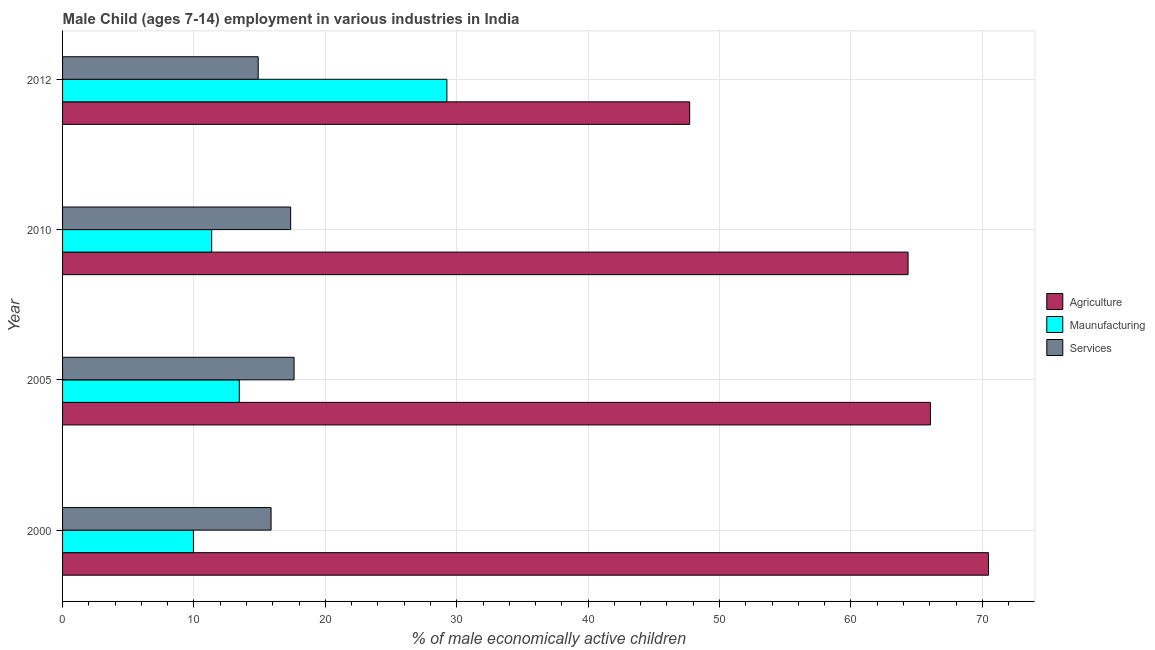How many different coloured bars are there?
Provide a succinct answer. 3. How many groups of bars are there?
Give a very brief answer. 4. How many bars are there on the 4th tick from the top?
Ensure brevity in your answer.  3. What is the percentage of economically active children in agriculture in 2010?
Your response must be concise. 64.35. Across all years, what is the maximum percentage of economically active children in agriculture?
Make the answer very short. 70.47. Across all years, what is the minimum percentage of economically active children in manufacturing?
Keep it short and to the point. 9.96. What is the total percentage of economically active children in manufacturing in the graph?
Provide a short and direct response. 64.01. What is the difference between the percentage of economically active children in services in 2000 and that in 2010?
Give a very brief answer. -1.49. What is the difference between the percentage of economically active children in agriculture in 2005 and the percentage of economically active children in manufacturing in 2012?
Your response must be concise. 36.8. What is the average percentage of economically active children in manufacturing per year?
Ensure brevity in your answer.  16. In the year 2010, what is the difference between the percentage of economically active children in manufacturing and percentage of economically active children in services?
Your answer should be compact. -6.01. In how many years, is the percentage of economically active children in manufacturing greater than 46 %?
Your response must be concise. 0. What is the ratio of the percentage of economically active children in agriculture in 2010 to that in 2012?
Your response must be concise. 1.35. Is the difference between the percentage of economically active children in manufacturing in 2000 and 2010 greater than the difference between the percentage of economically active children in agriculture in 2000 and 2010?
Your answer should be compact. No. What is the difference between the highest and the second highest percentage of economically active children in agriculture?
Your answer should be very brief. 4.42. What is the difference between the highest and the lowest percentage of economically active children in services?
Give a very brief answer. 2.73. What does the 3rd bar from the top in 2000 represents?
Your answer should be very brief. Agriculture. What does the 2nd bar from the bottom in 2012 represents?
Give a very brief answer. Maunufacturing. How many bars are there?
Your response must be concise. 12. What is the difference between two consecutive major ticks on the X-axis?
Offer a terse response. 10. Are the values on the major ticks of X-axis written in scientific E-notation?
Make the answer very short. No. Does the graph contain any zero values?
Your answer should be very brief. No. Where does the legend appear in the graph?
Your response must be concise. Center right. How many legend labels are there?
Your response must be concise. 3. How are the legend labels stacked?
Provide a short and direct response. Vertical. What is the title of the graph?
Offer a very short reply. Male Child (ages 7-14) employment in various industries in India. What is the label or title of the X-axis?
Offer a very short reply. % of male economically active children. What is the % of male economically active children in Agriculture in 2000?
Your answer should be very brief. 70.47. What is the % of male economically active children of Maunufacturing in 2000?
Your answer should be compact. 9.96. What is the % of male economically active children in Services in 2000?
Your answer should be compact. 15.87. What is the % of male economically active children in Agriculture in 2005?
Your response must be concise. 66.05. What is the % of male economically active children of Maunufacturing in 2005?
Provide a short and direct response. 13.45. What is the % of male economically active children of Services in 2005?
Give a very brief answer. 17.62. What is the % of male economically active children of Agriculture in 2010?
Your answer should be very brief. 64.35. What is the % of male economically active children in Maunufacturing in 2010?
Your answer should be very brief. 11.35. What is the % of male economically active children of Services in 2010?
Ensure brevity in your answer.  17.36. What is the % of male economically active children of Agriculture in 2012?
Keep it short and to the point. 47.73. What is the % of male economically active children of Maunufacturing in 2012?
Your answer should be very brief. 29.25. What is the % of male economically active children of Services in 2012?
Your response must be concise. 14.89. Across all years, what is the maximum % of male economically active children in Agriculture?
Your answer should be very brief. 70.47. Across all years, what is the maximum % of male economically active children of Maunufacturing?
Provide a succinct answer. 29.25. Across all years, what is the maximum % of male economically active children in Services?
Provide a succinct answer. 17.62. Across all years, what is the minimum % of male economically active children in Agriculture?
Provide a short and direct response. 47.73. Across all years, what is the minimum % of male economically active children of Maunufacturing?
Ensure brevity in your answer.  9.96. Across all years, what is the minimum % of male economically active children in Services?
Give a very brief answer. 14.89. What is the total % of male economically active children in Agriculture in the graph?
Offer a very short reply. 248.6. What is the total % of male economically active children of Maunufacturing in the graph?
Make the answer very short. 64.01. What is the total % of male economically active children in Services in the graph?
Ensure brevity in your answer.  65.74. What is the difference between the % of male economically active children in Agriculture in 2000 and that in 2005?
Provide a succinct answer. 4.42. What is the difference between the % of male economically active children of Maunufacturing in 2000 and that in 2005?
Provide a short and direct response. -3.49. What is the difference between the % of male economically active children of Services in 2000 and that in 2005?
Provide a short and direct response. -1.75. What is the difference between the % of male economically active children in Agriculture in 2000 and that in 2010?
Your answer should be compact. 6.12. What is the difference between the % of male economically active children of Maunufacturing in 2000 and that in 2010?
Provide a short and direct response. -1.39. What is the difference between the % of male economically active children in Services in 2000 and that in 2010?
Give a very brief answer. -1.49. What is the difference between the % of male economically active children in Agriculture in 2000 and that in 2012?
Your answer should be compact. 22.74. What is the difference between the % of male economically active children in Maunufacturing in 2000 and that in 2012?
Your answer should be very brief. -19.29. What is the difference between the % of male economically active children in Services in 2000 and that in 2012?
Keep it short and to the point. 0.98. What is the difference between the % of male economically active children of Agriculture in 2005 and that in 2010?
Provide a succinct answer. 1.7. What is the difference between the % of male economically active children of Services in 2005 and that in 2010?
Provide a succinct answer. 0.26. What is the difference between the % of male economically active children of Agriculture in 2005 and that in 2012?
Make the answer very short. 18.32. What is the difference between the % of male economically active children in Maunufacturing in 2005 and that in 2012?
Keep it short and to the point. -15.8. What is the difference between the % of male economically active children of Services in 2005 and that in 2012?
Provide a short and direct response. 2.73. What is the difference between the % of male economically active children of Agriculture in 2010 and that in 2012?
Offer a very short reply. 16.62. What is the difference between the % of male economically active children in Maunufacturing in 2010 and that in 2012?
Ensure brevity in your answer.  -17.9. What is the difference between the % of male economically active children of Services in 2010 and that in 2012?
Your answer should be very brief. 2.47. What is the difference between the % of male economically active children of Agriculture in 2000 and the % of male economically active children of Maunufacturing in 2005?
Give a very brief answer. 57.02. What is the difference between the % of male economically active children in Agriculture in 2000 and the % of male economically active children in Services in 2005?
Ensure brevity in your answer.  52.85. What is the difference between the % of male economically active children of Maunufacturing in 2000 and the % of male economically active children of Services in 2005?
Keep it short and to the point. -7.66. What is the difference between the % of male economically active children of Agriculture in 2000 and the % of male economically active children of Maunufacturing in 2010?
Ensure brevity in your answer.  59.12. What is the difference between the % of male economically active children in Agriculture in 2000 and the % of male economically active children in Services in 2010?
Your response must be concise. 53.11. What is the difference between the % of male economically active children of Maunufacturing in 2000 and the % of male economically active children of Services in 2010?
Make the answer very short. -7.4. What is the difference between the % of male economically active children of Agriculture in 2000 and the % of male economically active children of Maunufacturing in 2012?
Provide a short and direct response. 41.22. What is the difference between the % of male economically active children of Agriculture in 2000 and the % of male economically active children of Services in 2012?
Give a very brief answer. 55.58. What is the difference between the % of male economically active children of Maunufacturing in 2000 and the % of male economically active children of Services in 2012?
Offer a very short reply. -4.93. What is the difference between the % of male economically active children of Agriculture in 2005 and the % of male economically active children of Maunufacturing in 2010?
Ensure brevity in your answer.  54.7. What is the difference between the % of male economically active children in Agriculture in 2005 and the % of male economically active children in Services in 2010?
Provide a short and direct response. 48.69. What is the difference between the % of male economically active children of Maunufacturing in 2005 and the % of male economically active children of Services in 2010?
Provide a short and direct response. -3.91. What is the difference between the % of male economically active children in Agriculture in 2005 and the % of male economically active children in Maunufacturing in 2012?
Make the answer very short. 36.8. What is the difference between the % of male economically active children of Agriculture in 2005 and the % of male economically active children of Services in 2012?
Provide a short and direct response. 51.16. What is the difference between the % of male economically active children of Maunufacturing in 2005 and the % of male economically active children of Services in 2012?
Your response must be concise. -1.44. What is the difference between the % of male economically active children in Agriculture in 2010 and the % of male economically active children in Maunufacturing in 2012?
Your response must be concise. 35.1. What is the difference between the % of male economically active children of Agriculture in 2010 and the % of male economically active children of Services in 2012?
Make the answer very short. 49.46. What is the difference between the % of male economically active children in Maunufacturing in 2010 and the % of male economically active children in Services in 2012?
Offer a very short reply. -3.54. What is the average % of male economically active children of Agriculture per year?
Provide a short and direct response. 62.15. What is the average % of male economically active children of Maunufacturing per year?
Ensure brevity in your answer.  16. What is the average % of male economically active children of Services per year?
Offer a terse response. 16.43. In the year 2000, what is the difference between the % of male economically active children of Agriculture and % of male economically active children of Maunufacturing?
Your response must be concise. 60.51. In the year 2000, what is the difference between the % of male economically active children of Agriculture and % of male economically active children of Services?
Your answer should be compact. 54.6. In the year 2000, what is the difference between the % of male economically active children in Maunufacturing and % of male economically active children in Services?
Your answer should be very brief. -5.91. In the year 2005, what is the difference between the % of male economically active children of Agriculture and % of male economically active children of Maunufacturing?
Your answer should be very brief. 52.6. In the year 2005, what is the difference between the % of male economically active children of Agriculture and % of male economically active children of Services?
Offer a terse response. 48.43. In the year 2005, what is the difference between the % of male economically active children in Maunufacturing and % of male economically active children in Services?
Offer a very short reply. -4.17. In the year 2010, what is the difference between the % of male economically active children in Agriculture and % of male economically active children in Maunufacturing?
Your response must be concise. 53. In the year 2010, what is the difference between the % of male economically active children of Agriculture and % of male economically active children of Services?
Your answer should be compact. 46.99. In the year 2010, what is the difference between the % of male economically active children of Maunufacturing and % of male economically active children of Services?
Offer a very short reply. -6.01. In the year 2012, what is the difference between the % of male economically active children in Agriculture and % of male economically active children in Maunufacturing?
Offer a very short reply. 18.48. In the year 2012, what is the difference between the % of male economically active children in Agriculture and % of male economically active children in Services?
Ensure brevity in your answer.  32.84. In the year 2012, what is the difference between the % of male economically active children in Maunufacturing and % of male economically active children in Services?
Keep it short and to the point. 14.36. What is the ratio of the % of male economically active children in Agriculture in 2000 to that in 2005?
Make the answer very short. 1.07. What is the ratio of the % of male economically active children of Maunufacturing in 2000 to that in 2005?
Offer a very short reply. 0.74. What is the ratio of the % of male economically active children in Services in 2000 to that in 2005?
Provide a short and direct response. 0.9. What is the ratio of the % of male economically active children in Agriculture in 2000 to that in 2010?
Offer a terse response. 1.1. What is the ratio of the % of male economically active children of Maunufacturing in 2000 to that in 2010?
Keep it short and to the point. 0.88. What is the ratio of the % of male economically active children in Services in 2000 to that in 2010?
Offer a terse response. 0.91. What is the ratio of the % of male economically active children of Agriculture in 2000 to that in 2012?
Provide a succinct answer. 1.48. What is the ratio of the % of male economically active children in Maunufacturing in 2000 to that in 2012?
Provide a short and direct response. 0.34. What is the ratio of the % of male economically active children of Services in 2000 to that in 2012?
Keep it short and to the point. 1.07. What is the ratio of the % of male economically active children of Agriculture in 2005 to that in 2010?
Offer a terse response. 1.03. What is the ratio of the % of male economically active children of Maunufacturing in 2005 to that in 2010?
Make the answer very short. 1.19. What is the ratio of the % of male economically active children in Agriculture in 2005 to that in 2012?
Give a very brief answer. 1.38. What is the ratio of the % of male economically active children of Maunufacturing in 2005 to that in 2012?
Your answer should be very brief. 0.46. What is the ratio of the % of male economically active children in Services in 2005 to that in 2012?
Provide a succinct answer. 1.18. What is the ratio of the % of male economically active children of Agriculture in 2010 to that in 2012?
Your answer should be very brief. 1.35. What is the ratio of the % of male economically active children in Maunufacturing in 2010 to that in 2012?
Give a very brief answer. 0.39. What is the ratio of the % of male economically active children in Services in 2010 to that in 2012?
Keep it short and to the point. 1.17. What is the difference between the highest and the second highest % of male economically active children in Agriculture?
Give a very brief answer. 4.42. What is the difference between the highest and the second highest % of male economically active children in Maunufacturing?
Ensure brevity in your answer.  15.8. What is the difference between the highest and the second highest % of male economically active children in Services?
Provide a short and direct response. 0.26. What is the difference between the highest and the lowest % of male economically active children of Agriculture?
Provide a succinct answer. 22.74. What is the difference between the highest and the lowest % of male economically active children in Maunufacturing?
Offer a terse response. 19.29. What is the difference between the highest and the lowest % of male economically active children of Services?
Give a very brief answer. 2.73. 